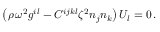Convert formula to latex. <formula><loc_0><loc_0><loc_500><loc_500>\left ( \rho \, \omega ^ { 2 } g ^ { i l } - C ^ { i j k l } \zeta ^ { 2 } n _ { j } n _ { k } \right ) U _ { l } = 0 \, .</formula> 